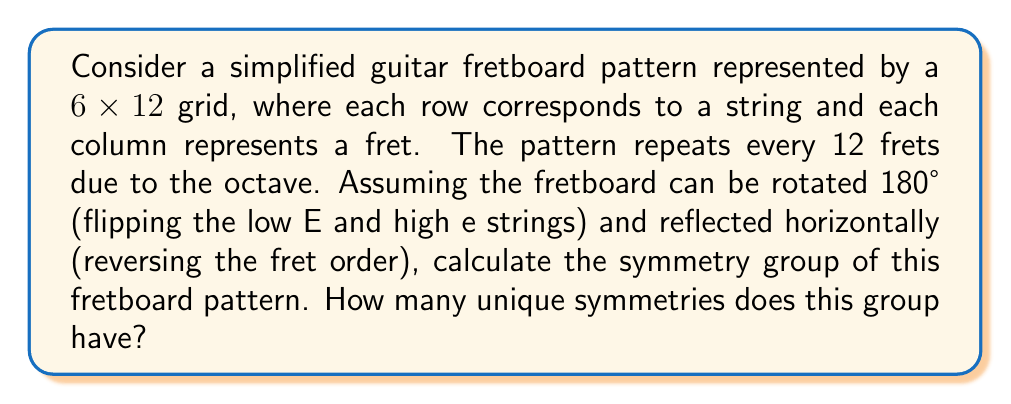Show me your answer to this math problem. Let's approach this step-by-step:

1) First, we need to identify the possible symmetry operations:

   a) Identity (I): Leaving the fretboard as is.
   b) Rotation (R): Rotating the fretboard 180°, flipping the strings.
   c) Reflection (H): Reflecting the fretboard horizontally, reversing the fret order.
   d) Rotation followed by Reflection (RH): Combining operations b and c.

2) These operations form a group under composition. Let's verify:

   - Closure: Applying any two operations always results in one of these four.
   - Associativity: This is inherent in geometric transformations.
   - Identity: The identity operation (I) exists.
   - Inverse: Each operation is its own inverse (I^2 = R^2 = H^2 = (RH)^2 = I).

3) We can represent this group with the following Cayley table:

   $$
   \begin{array}{c|cccc}
   \circ & I & R & H & RH \\
   \hline
   I & I & R & H & RH \\
   R & R & I & RH & H \\
   H & H & RH & I & R \\
   RH & RH & H & R & I
   \end{array}
   $$

4) This group structure is isomorphic to the Klein four-group, $V_4$ or $C_2 \times C_2$.

5) The order of this group (number of unique symmetries) is 4.

From an artistic perspective, these symmetries represent different ways of viewing or hearing the fretboard pattern, each potentially offering a unique musical perspective without altering the fundamental structure of the instrument.
Answer: The symmetry group of the simplified guitar fretboard pattern is isomorphic to the Klein four-group ($V_4$), with 4 unique symmetries. 